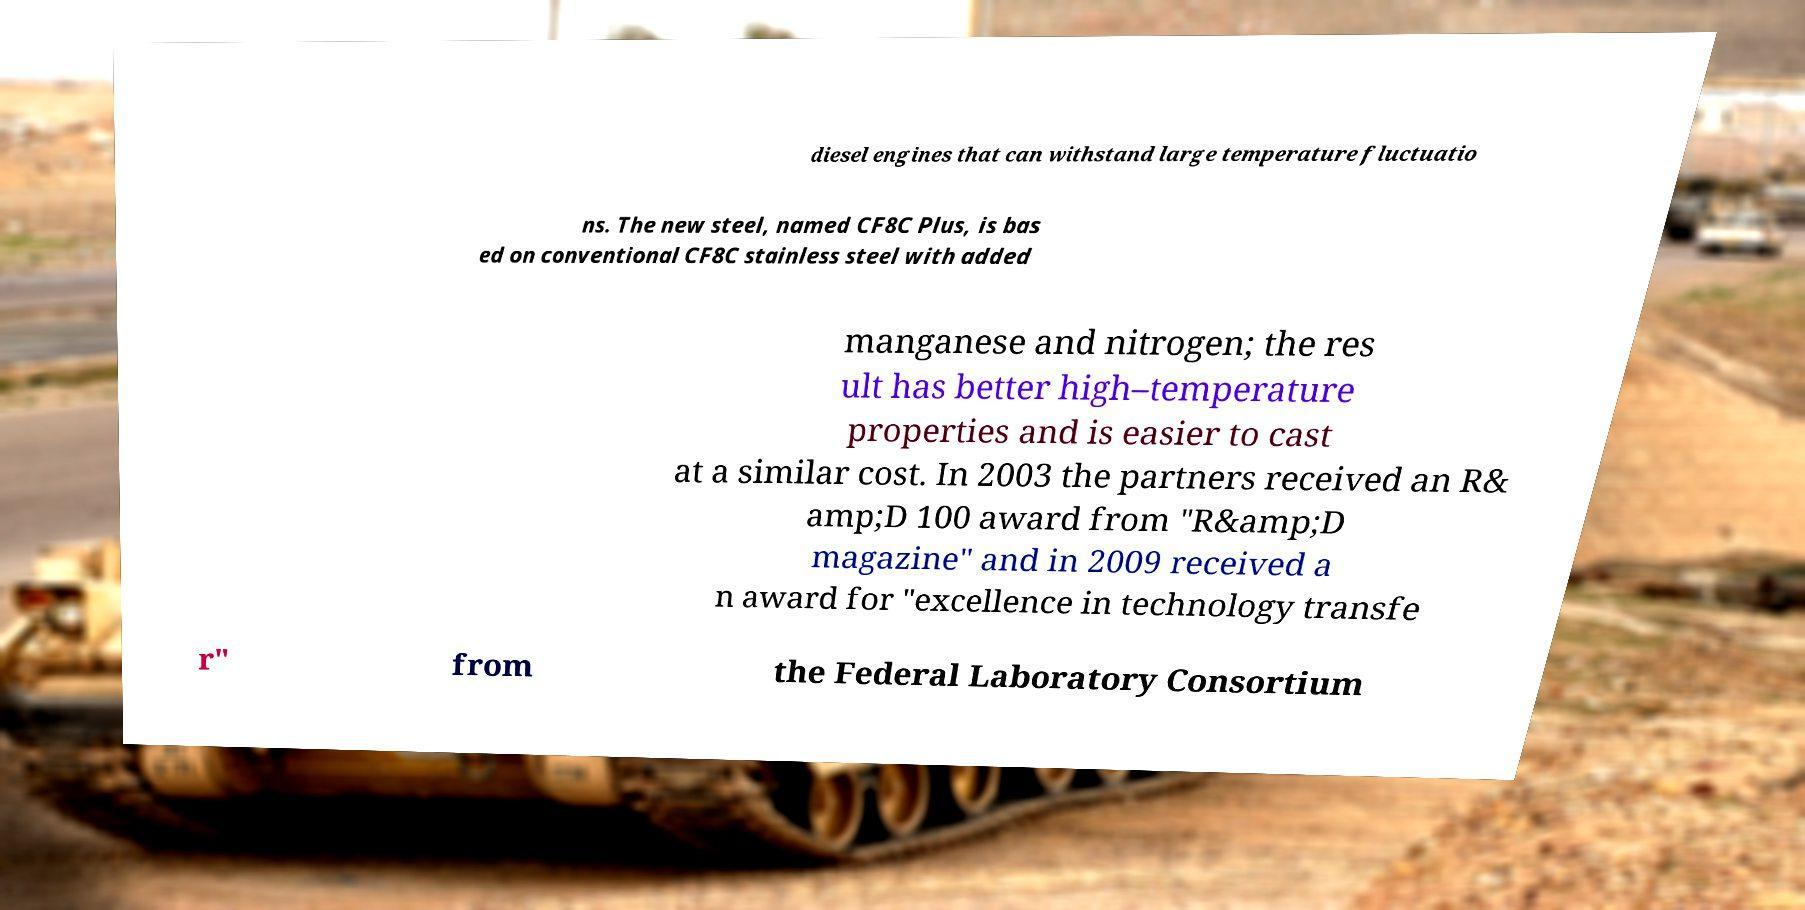Can you read and provide the text displayed in the image?This photo seems to have some interesting text. Can you extract and type it out for me? diesel engines that can withstand large temperature fluctuatio ns. The new steel, named CF8C Plus, is bas ed on conventional CF8C stainless steel with added manganese and nitrogen; the res ult has better high–temperature properties and is easier to cast at a similar cost. In 2003 the partners received an R& amp;D 100 award from "R&amp;D magazine" and in 2009 received a n award for "excellence in technology transfe r" from the Federal Laboratory Consortium 